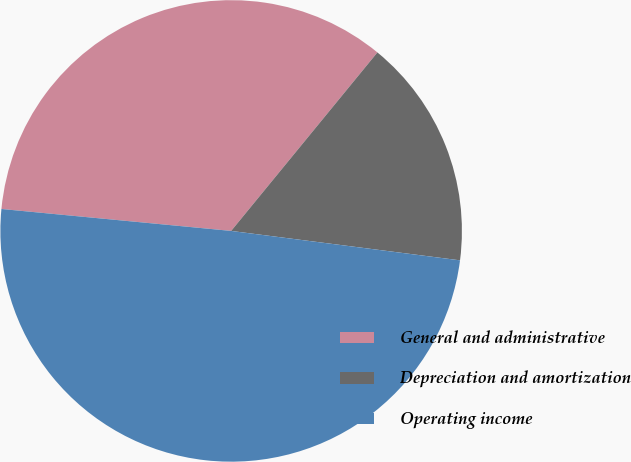Convert chart. <chart><loc_0><loc_0><loc_500><loc_500><pie_chart><fcel>General and administrative<fcel>Depreciation and amortization<fcel>Operating income<nl><fcel>34.41%<fcel>16.11%<fcel>49.48%<nl></chart> 